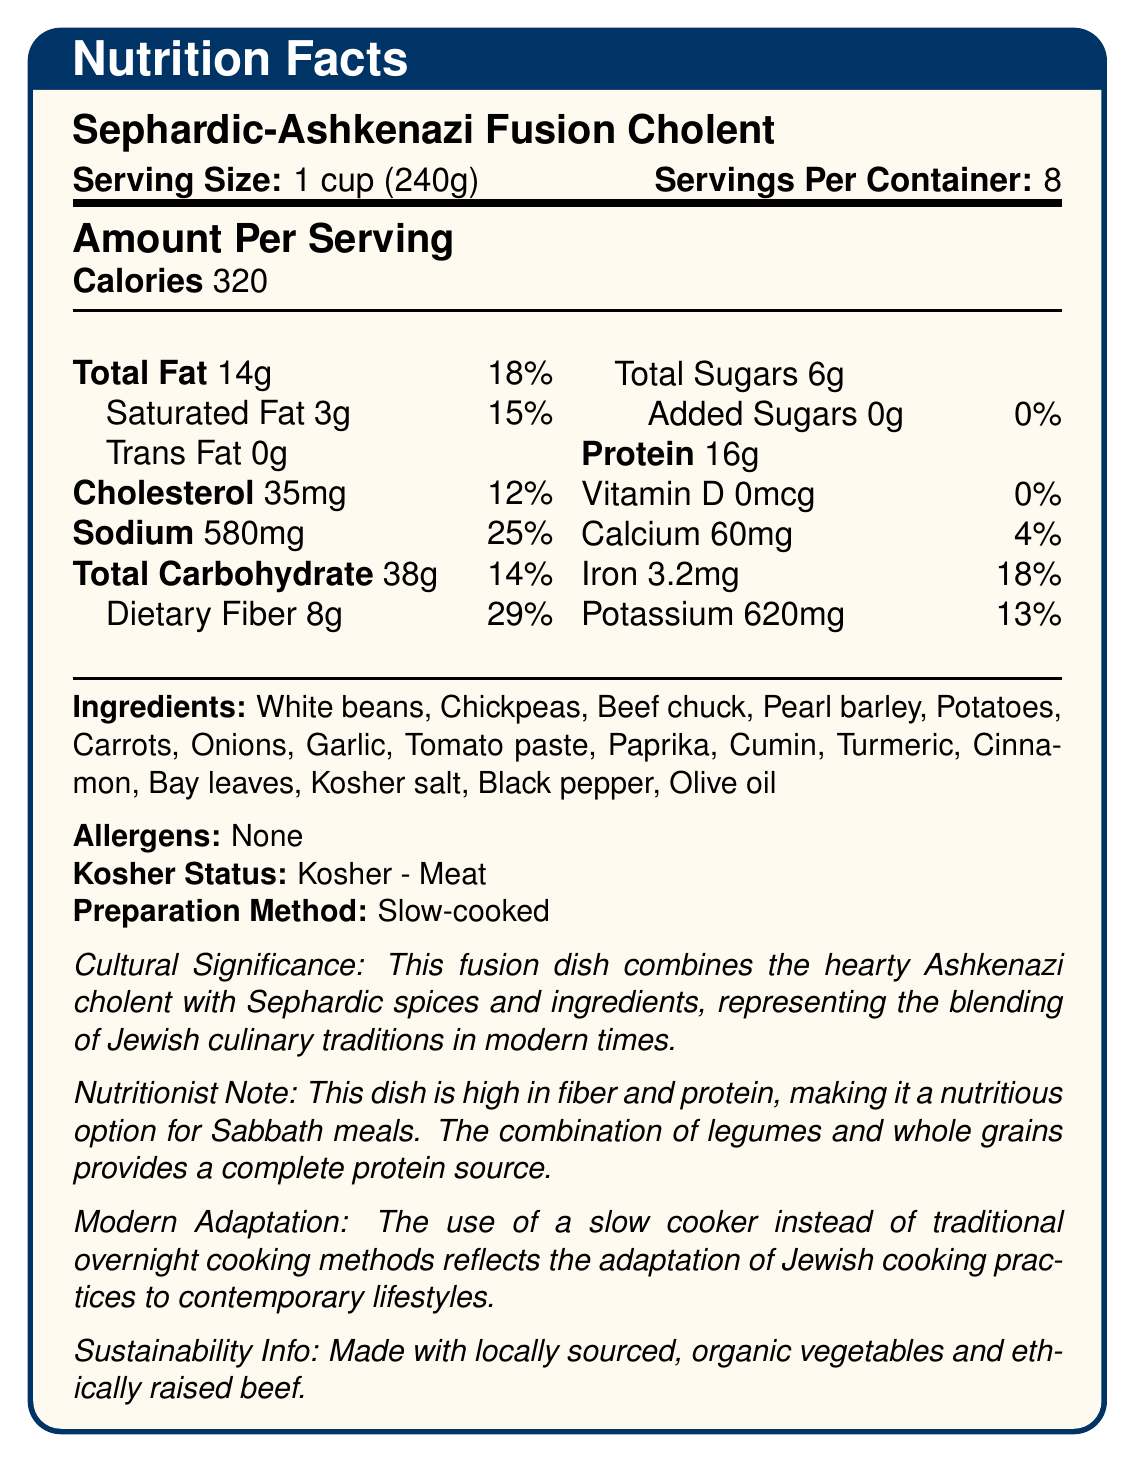what is the serving size? The serving size is explicitly mentioned as 1 cup (240g).
Answer: 1 cup (240g) how many servings are in the container? The document states there are 8 servings per container.
Answer: 8 how many calories are there per serving? Each serving contains 320 calories, as stated in the document.
Answer: 320 what is the total amount of dietary fiber per serving? The total dietary fiber per serving is listed as 8g.
Answer: 8g What is the cholesterol content per serving? The document specifies that the cholesterol content is 35mg per serving.
Answer: 35mg Does the dish contain any added sugars? The added sugars are listed as 0g, with a daily value of 0%.
Answer: No Is this dish suitable for someone following a kosher diet? The document indicates the dish has kosher status marked as "Kosher - Meat."
Answer: Yes What is the protein content per serving? Per serving, the dish contains 16g of protein.
Answer: 16g What ingredient is not included in this fusion dish? Celery is not listed among the ingredients.
Answer: D. Celery What is the preparation method for this dish? The preparation method is explicitly labeled as slow-cooked.
Answer: C. Slow-cooked What makes this dish a fusion between Ashkenazi and Sephardic traditions? The cultural significance section describes how this dish represents a blend of Jewish culinary traditions by combining elements from both Ashkenazi and Sephardic cooking.
Answer: The dish combines the hearty Ashkenazi cholent with Sephardic spices and ingredients, representing the blending of Jewish culinary traditions in modern times. Was this dish made with sustainably sourced ingredients? The Sustainability Info section states that it is made with locally sourced, organic vegetables and ethically raised beef.
Answer: Yes Identify two spices used in this dish. The ingredients list includes both paprika and cumin.
Answer: Paprika and Cumin What modern adaptation is noted in the preparation of this dish? The document mentions that the slow cooker is a modern adaptation reflecting contemporary lifestyles.
Answer: The use of a slow cooker instead of traditional overnight cooking methods How much iron is present per serving, and what is its daily value percentage? The iron content is listed as 3.2mg per serving with a daily value of 18%.
Answer: 3.2mg, 18% What is the cultural significance of this dish? This is explicitly stated in the document under cultural significance.
Answer: This fusion dish combines the hearty Ashkenazi cholent with Sephardic spices and ingredients, representing the blending of Jewish culinary traditions in modern times. Summarize the entire document. A comprehensive summary involves synthesizing all sections of the document, including nutrition facts, ingredients, preparation method, cultural significance, and additional notes.
Answer: This document presents the nutrition facts for Sephardic-Ashkenazi Fusion Cholent, with detailed information on serving size, servings per container, various nutrient contents, ingredients, kosher status, and allergens. It highlights the dish's cultural significance, modern adaptation, and sustainability information, characterizing it as a nutritious, slow-cooked fusion of Ashkenazi and Sephardic Jewish culinary traditions. What is the amount of Vitamin C per serving? The document does not provide information on Vitamin C content.
Answer: Not enough information 